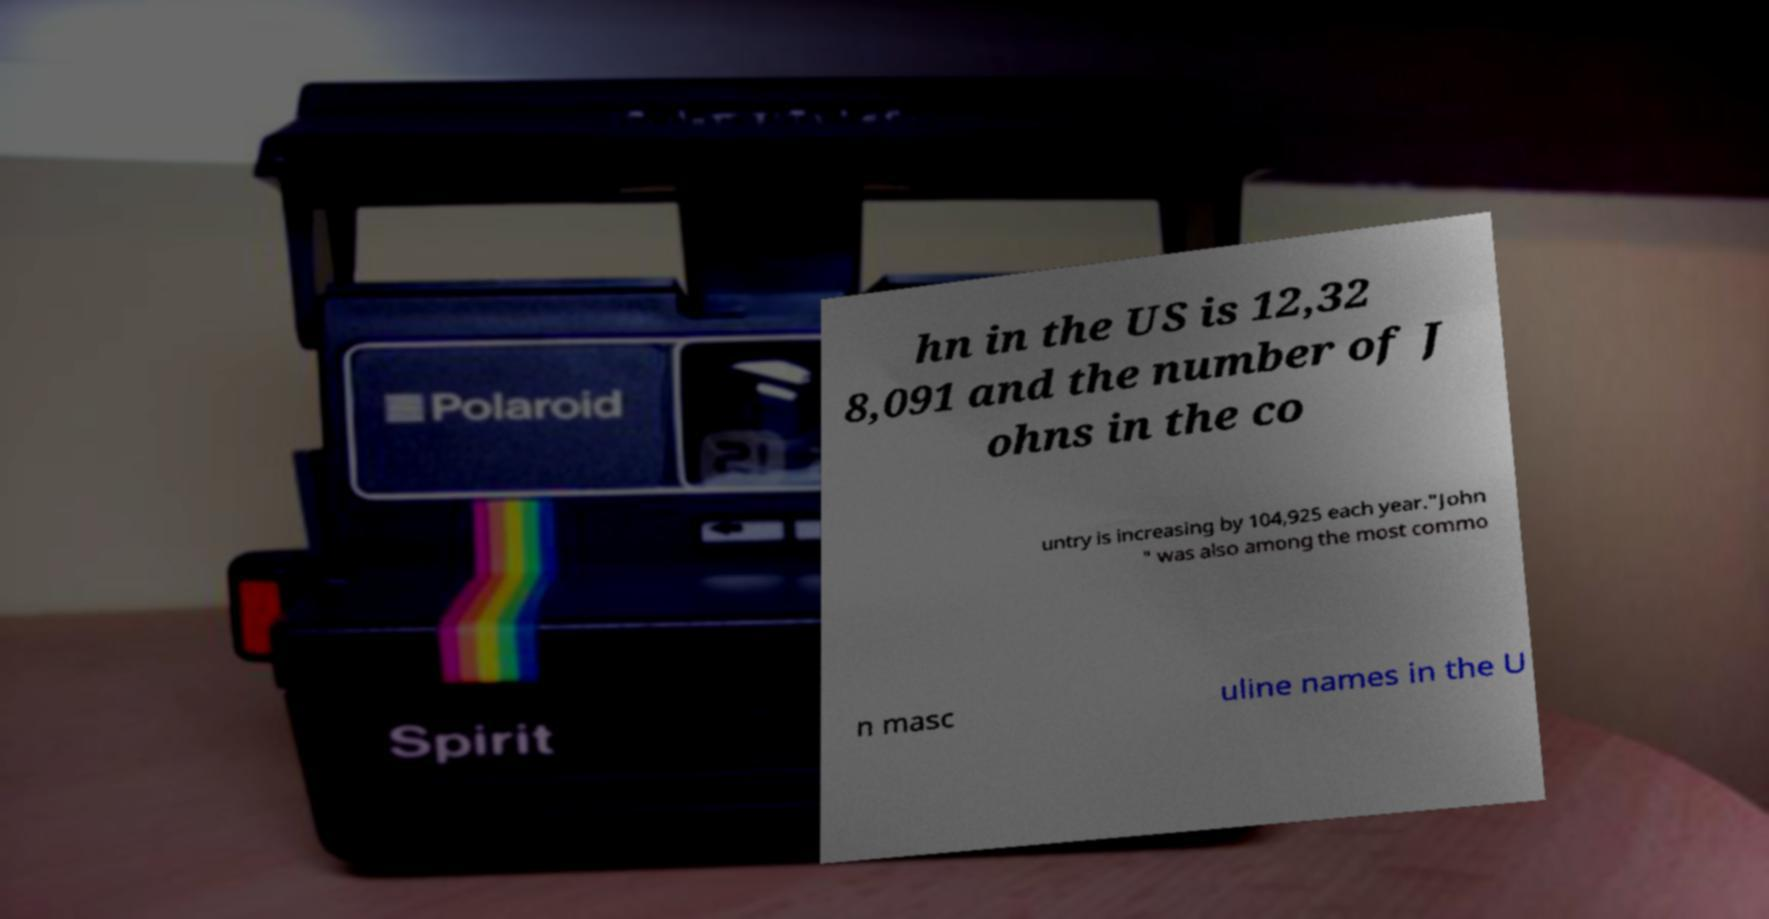Can you accurately transcribe the text from the provided image for me? hn in the US is 12,32 8,091 and the number of J ohns in the co untry is increasing by 104,925 each year."John " was also among the most commo n masc uline names in the U 